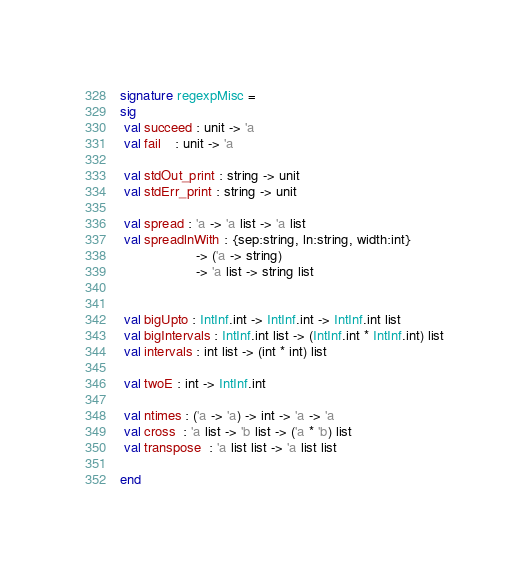<code> <loc_0><loc_0><loc_500><loc_500><_SML_>signature regexpMisc =
sig
 val succeed : unit -> 'a
 val fail    : unit -> 'a

 val stdOut_print : string -> unit
 val stdErr_print : string -> unit

 val spread : 'a -> 'a list -> 'a list
 val spreadlnWith : {sep:string, ln:string, width:int}
                    -> ('a -> string)
                    -> 'a list -> string list


 val bigUpto : IntInf.int -> IntInf.int -> IntInf.int list
 val bigIntervals : IntInf.int list -> (IntInf.int * IntInf.int) list
 val intervals : int list -> (int * int) list

 val twoE : int -> IntInf.int

 val ntimes : ('a -> 'a) -> int -> 'a -> 'a
 val cross  : 'a list -> 'b list -> ('a * 'b) list
 val transpose  : 'a list list -> 'a list list

end
</code> 